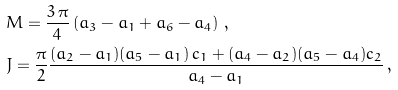<formula> <loc_0><loc_0><loc_500><loc_500>& M = \frac { 3 \, \pi } { 4 } \left ( a _ { 3 } - a _ { 1 } + a _ { 6 } - a _ { 4 } \right ) \, , \\ & J = \frac { \pi } { 2 } \frac { ( a _ { 2 } - a _ { 1 } ) ( a _ { 5 } - a _ { 1 } ) \, c _ { 1 } + ( a _ { 4 } - a _ { 2 } ) ( a _ { 5 } - a _ { 4 } ) c _ { 2 } } { a _ { 4 } - a _ { 1 } } \, ,</formula> 